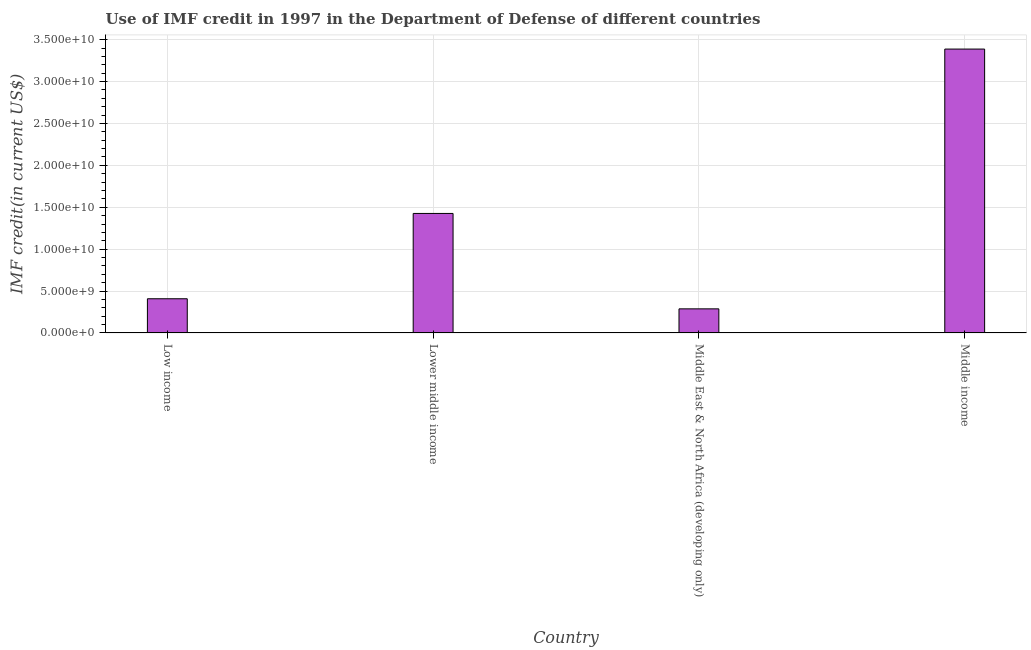Does the graph contain any zero values?
Ensure brevity in your answer.  No. Does the graph contain grids?
Offer a very short reply. Yes. What is the title of the graph?
Make the answer very short. Use of IMF credit in 1997 in the Department of Defense of different countries. What is the label or title of the Y-axis?
Your response must be concise. IMF credit(in current US$). What is the use of imf credit in dod in Low income?
Give a very brief answer. 4.08e+09. Across all countries, what is the maximum use of imf credit in dod?
Give a very brief answer. 3.39e+1. Across all countries, what is the minimum use of imf credit in dod?
Offer a very short reply. 2.87e+09. In which country was the use of imf credit in dod minimum?
Offer a very short reply. Middle East & North Africa (developing only). What is the sum of the use of imf credit in dod?
Your answer should be compact. 5.51e+1. What is the difference between the use of imf credit in dod in Low income and Middle East & North Africa (developing only)?
Your response must be concise. 1.21e+09. What is the average use of imf credit in dod per country?
Provide a succinct answer. 1.38e+1. What is the median use of imf credit in dod?
Give a very brief answer. 9.17e+09. In how many countries, is the use of imf credit in dod greater than 33000000000 US$?
Provide a short and direct response. 1. What is the ratio of the use of imf credit in dod in Low income to that in Lower middle income?
Provide a succinct answer. 0.29. What is the difference between the highest and the second highest use of imf credit in dod?
Ensure brevity in your answer.  1.96e+1. What is the difference between the highest and the lowest use of imf credit in dod?
Provide a succinct answer. 3.10e+1. In how many countries, is the use of imf credit in dod greater than the average use of imf credit in dod taken over all countries?
Your response must be concise. 2. How many bars are there?
Provide a short and direct response. 4. Are all the bars in the graph horizontal?
Keep it short and to the point. No. How many countries are there in the graph?
Offer a very short reply. 4. What is the IMF credit(in current US$) of Low income?
Provide a short and direct response. 4.08e+09. What is the IMF credit(in current US$) in Lower middle income?
Make the answer very short. 1.43e+1. What is the IMF credit(in current US$) in Middle East & North Africa (developing only)?
Your response must be concise. 2.87e+09. What is the IMF credit(in current US$) in Middle income?
Offer a very short reply. 3.39e+1. What is the difference between the IMF credit(in current US$) in Low income and Lower middle income?
Make the answer very short. -1.02e+1. What is the difference between the IMF credit(in current US$) in Low income and Middle East & North Africa (developing only)?
Keep it short and to the point. 1.21e+09. What is the difference between the IMF credit(in current US$) in Low income and Middle income?
Your answer should be compact. -2.98e+1. What is the difference between the IMF credit(in current US$) in Lower middle income and Middle East & North Africa (developing only)?
Give a very brief answer. 1.14e+1. What is the difference between the IMF credit(in current US$) in Lower middle income and Middle income?
Your response must be concise. -1.96e+1. What is the difference between the IMF credit(in current US$) in Middle East & North Africa (developing only) and Middle income?
Give a very brief answer. -3.10e+1. What is the ratio of the IMF credit(in current US$) in Low income to that in Lower middle income?
Keep it short and to the point. 0.29. What is the ratio of the IMF credit(in current US$) in Low income to that in Middle East & North Africa (developing only)?
Offer a very short reply. 1.42. What is the ratio of the IMF credit(in current US$) in Low income to that in Middle income?
Give a very brief answer. 0.12. What is the ratio of the IMF credit(in current US$) in Lower middle income to that in Middle East & North Africa (developing only)?
Provide a succinct answer. 4.96. What is the ratio of the IMF credit(in current US$) in Lower middle income to that in Middle income?
Ensure brevity in your answer.  0.42. What is the ratio of the IMF credit(in current US$) in Middle East & North Africa (developing only) to that in Middle income?
Give a very brief answer. 0.09. 